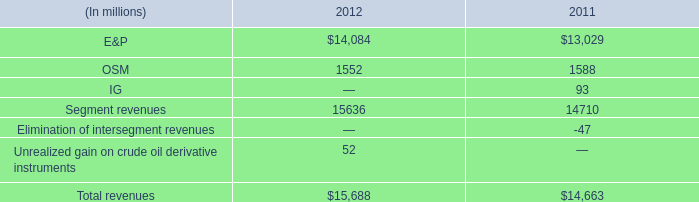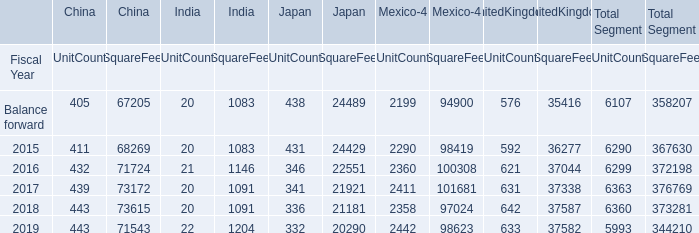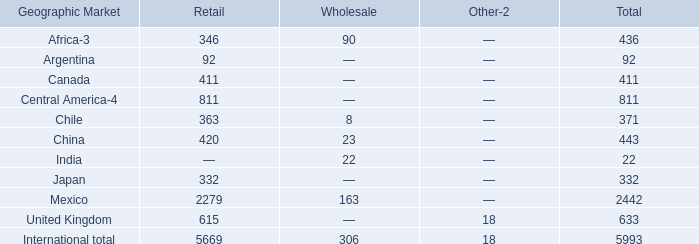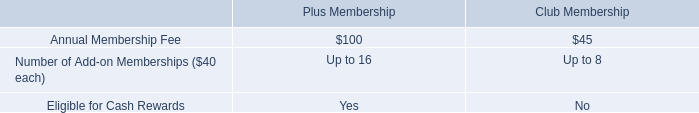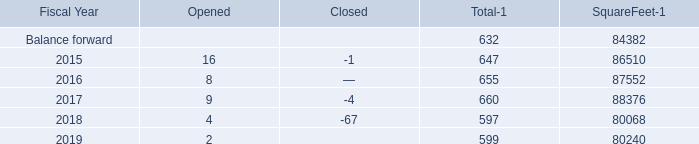by how much did total revenue increase from 2011 to 2012? 
Computations: ((15688 - 14663) / 14663)
Answer: 0.0699. 